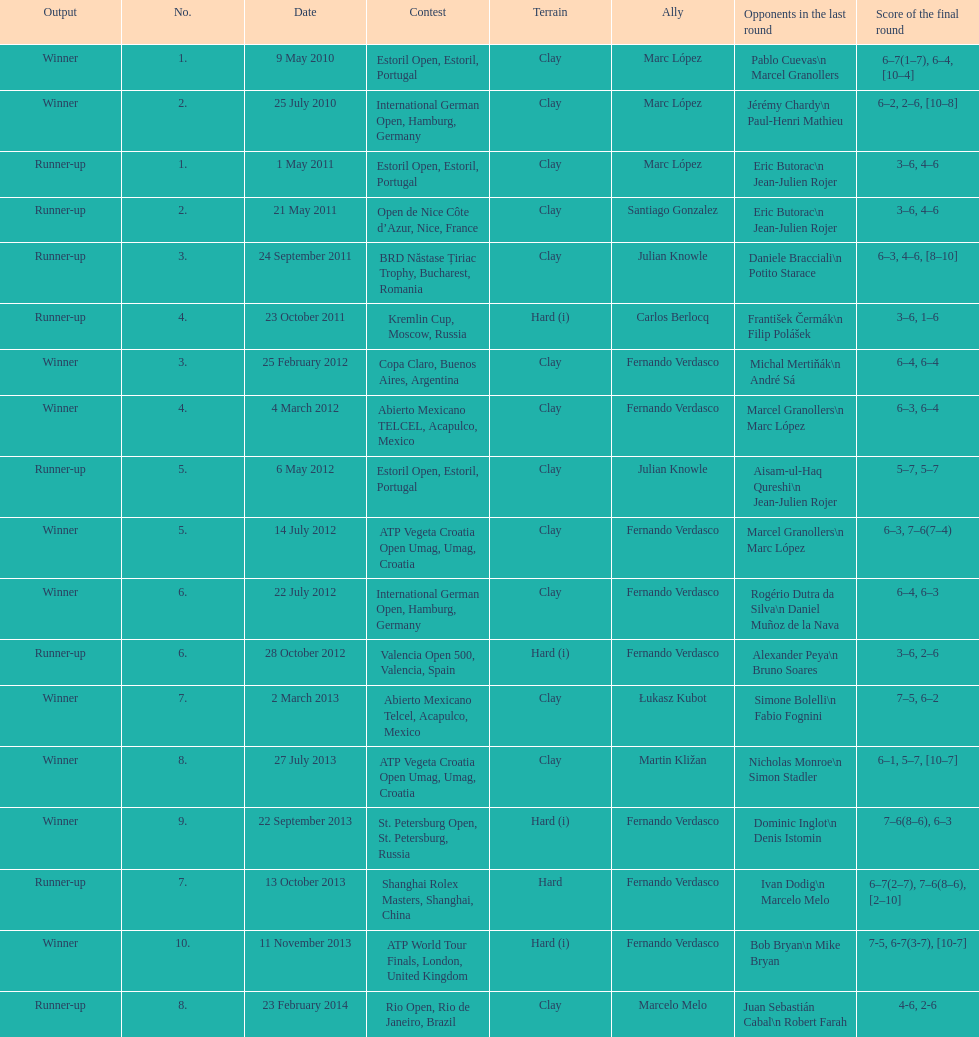How many tournaments has this player won in his career so far? 10. Would you be able to parse every entry in this table? {'header': ['Output', 'No.', 'Date', 'Contest', 'Terrain', 'Ally', 'Opponents in the last round', 'Score of the final round'], 'rows': [['Winner', '1.', '9 May 2010', 'Estoril Open, Estoril, Portugal', 'Clay', 'Marc López', 'Pablo Cuevas\\n Marcel Granollers', '6–7(1–7), 6–4, [10–4]'], ['Winner', '2.', '25 July 2010', 'International German Open, Hamburg, Germany', 'Clay', 'Marc López', 'Jérémy Chardy\\n Paul-Henri Mathieu', '6–2, 2–6, [10–8]'], ['Runner-up', '1.', '1 May 2011', 'Estoril Open, Estoril, Portugal', 'Clay', 'Marc López', 'Eric Butorac\\n Jean-Julien Rojer', '3–6, 4–6'], ['Runner-up', '2.', '21 May 2011', 'Open de Nice Côte d’Azur, Nice, France', 'Clay', 'Santiago Gonzalez', 'Eric Butorac\\n Jean-Julien Rojer', '3–6, 4–6'], ['Runner-up', '3.', '24 September 2011', 'BRD Năstase Țiriac Trophy, Bucharest, Romania', 'Clay', 'Julian Knowle', 'Daniele Bracciali\\n Potito Starace', '6–3, 4–6, [8–10]'], ['Runner-up', '4.', '23 October 2011', 'Kremlin Cup, Moscow, Russia', 'Hard (i)', 'Carlos Berlocq', 'František Čermák\\n Filip Polášek', '3–6, 1–6'], ['Winner', '3.', '25 February 2012', 'Copa Claro, Buenos Aires, Argentina', 'Clay', 'Fernando Verdasco', 'Michal Mertiňák\\n André Sá', '6–4, 6–4'], ['Winner', '4.', '4 March 2012', 'Abierto Mexicano TELCEL, Acapulco, Mexico', 'Clay', 'Fernando Verdasco', 'Marcel Granollers\\n Marc López', '6–3, 6–4'], ['Runner-up', '5.', '6 May 2012', 'Estoril Open, Estoril, Portugal', 'Clay', 'Julian Knowle', 'Aisam-ul-Haq Qureshi\\n Jean-Julien Rojer', '5–7, 5–7'], ['Winner', '5.', '14 July 2012', 'ATP Vegeta Croatia Open Umag, Umag, Croatia', 'Clay', 'Fernando Verdasco', 'Marcel Granollers\\n Marc López', '6–3, 7–6(7–4)'], ['Winner', '6.', '22 July 2012', 'International German Open, Hamburg, Germany', 'Clay', 'Fernando Verdasco', 'Rogério Dutra da Silva\\n Daniel Muñoz de la Nava', '6–4, 6–3'], ['Runner-up', '6.', '28 October 2012', 'Valencia Open 500, Valencia, Spain', 'Hard (i)', 'Fernando Verdasco', 'Alexander Peya\\n Bruno Soares', '3–6, 2–6'], ['Winner', '7.', '2 March 2013', 'Abierto Mexicano Telcel, Acapulco, Mexico', 'Clay', 'Łukasz Kubot', 'Simone Bolelli\\n Fabio Fognini', '7–5, 6–2'], ['Winner', '8.', '27 July 2013', 'ATP Vegeta Croatia Open Umag, Umag, Croatia', 'Clay', 'Martin Kližan', 'Nicholas Monroe\\n Simon Stadler', '6–1, 5–7, [10–7]'], ['Winner', '9.', '22 September 2013', 'St. Petersburg Open, St. Petersburg, Russia', 'Hard (i)', 'Fernando Verdasco', 'Dominic Inglot\\n Denis Istomin', '7–6(8–6), 6–3'], ['Runner-up', '7.', '13 October 2013', 'Shanghai Rolex Masters, Shanghai, China', 'Hard', 'Fernando Verdasco', 'Ivan Dodig\\n Marcelo Melo', '6–7(2–7), 7–6(8–6), [2–10]'], ['Winner', '10.', '11 November 2013', 'ATP World Tour Finals, London, United Kingdom', 'Hard (i)', 'Fernando Verdasco', 'Bob Bryan\\n Mike Bryan', '7-5, 6-7(3-7), [10-7]'], ['Runner-up', '8.', '23 February 2014', 'Rio Open, Rio de Janeiro, Brazil', 'Clay', 'Marcelo Melo', 'Juan Sebastián Cabal\\n Robert Farah', '4-6, 2-6']]} 